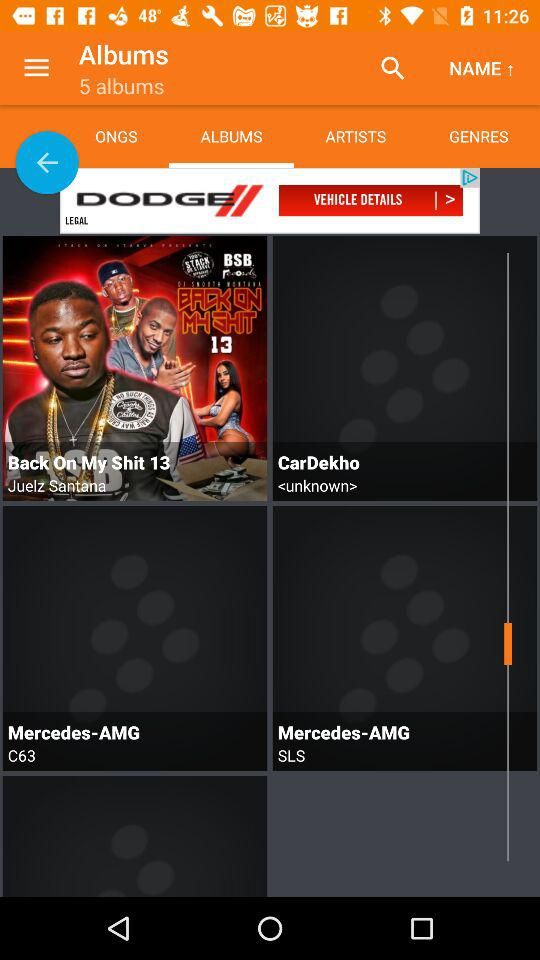How many albums in total are there? There are 5 albums. 